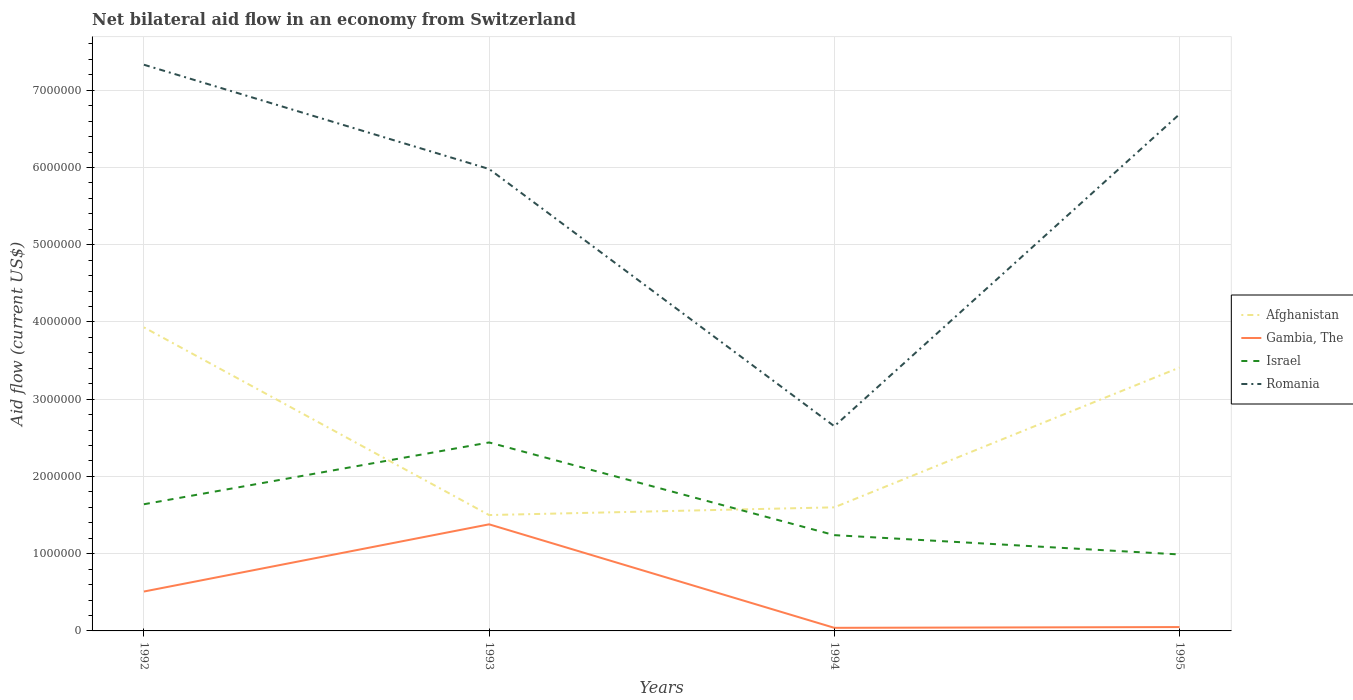Does the line corresponding to Israel intersect with the line corresponding to Afghanistan?
Provide a succinct answer. Yes. Is the number of lines equal to the number of legend labels?
Offer a very short reply. Yes. Across all years, what is the maximum net bilateral aid flow in Israel?
Offer a terse response. 9.90e+05. In which year was the net bilateral aid flow in Romania maximum?
Your answer should be compact. 1994. What is the total net bilateral aid flow in Israel in the graph?
Your answer should be very brief. 2.50e+05. What is the difference between the highest and the second highest net bilateral aid flow in Gambia, The?
Offer a very short reply. 1.34e+06. What is the difference between the highest and the lowest net bilateral aid flow in Romania?
Your answer should be compact. 3. How many lines are there?
Provide a short and direct response. 4. How many years are there in the graph?
Your answer should be compact. 4. What is the difference between two consecutive major ticks on the Y-axis?
Offer a terse response. 1.00e+06. Are the values on the major ticks of Y-axis written in scientific E-notation?
Your response must be concise. No. Does the graph contain any zero values?
Your answer should be compact. No. Where does the legend appear in the graph?
Your answer should be compact. Center right. How many legend labels are there?
Give a very brief answer. 4. How are the legend labels stacked?
Your response must be concise. Vertical. What is the title of the graph?
Offer a terse response. Net bilateral aid flow in an economy from Switzerland. What is the label or title of the Y-axis?
Ensure brevity in your answer.  Aid flow (current US$). What is the Aid flow (current US$) of Afghanistan in 1992?
Keep it short and to the point. 3.93e+06. What is the Aid flow (current US$) of Gambia, The in 1992?
Your answer should be compact. 5.10e+05. What is the Aid flow (current US$) of Israel in 1992?
Make the answer very short. 1.64e+06. What is the Aid flow (current US$) in Romania in 1992?
Provide a short and direct response. 7.33e+06. What is the Aid flow (current US$) of Afghanistan in 1993?
Your answer should be compact. 1.50e+06. What is the Aid flow (current US$) in Gambia, The in 1993?
Your response must be concise. 1.38e+06. What is the Aid flow (current US$) in Israel in 1993?
Your answer should be compact. 2.44e+06. What is the Aid flow (current US$) of Romania in 1993?
Provide a succinct answer. 5.98e+06. What is the Aid flow (current US$) of Afghanistan in 1994?
Your answer should be compact. 1.60e+06. What is the Aid flow (current US$) in Israel in 1994?
Your answer should be very brief. 1.24e+06. What is the Aid flow (current US$) of Romania in 1994?
Provide a succinct answer. 2.65e+06. What is the Aid flow (current US$) in Afghanistan in 1995?
Give a very brief answer. 3.41e+06. What is the Aid flow (current US$) of Israel in 1995?
Ensure brevity in your answer.  9.90e+05. What is the Aid flow (current US$) of Romania in 1995?
Your answer should be compact. 6.69e+06. Across all years, what is the maximum Aid flow (current US$) of Afghanistan?
Offer a very short reply. 3.93e+06. Across all years, what is the maximum Aid flow (current US$) of Gambia, The?
Your response must be concise. 1.38e+06. Across all years, what is the maximum Aid flow (current US$) in Israel?
Your answer should be very brief. 2.44e+06. Across all years, what is the maximum Aid flow (current US$) of Romania?
Ensure brevity in your answer.  7.33e+06. Across all years, what is the minimum Aid flow (current US$) of Afghanistan?
Provide a short and direct response. 1.50e+06. Across all years, what is the minimum Aid flow (current US$) of Gambia, The?
Offer a terse response. 4.00e+04. Across all years, what is the minimum Aid flow (current US$) of Israel?
Keep it short and to the point. 9.90e+05. Across all years, what is the minimum Aid flow (current US$) in Romania?
Your response must be concise. 2.65e+06. What is the total Aid flow (current US$) of Afghanistan in the graph?
Your response must be concise. 1.04e+07. What is the total Aid flow (current US$) of Gambia, The in the graph?
Offer a terse response. 1.98e+06. What is the total Aid flow (current US$) in Israel in the graph?
Provide a short and direct response. 6.31e+06. What is the total Aid flow (current US$) of Romania in the graph?
Provide a succinct answer. 2.26e+07. What is the difference between the Aid flow (current US$) of Afghanistan in 1992 and that in 1993?
Offer a terse response. 2.43e+06. What is the difference between the Aid flow (current US$) in Gambia, The in 1992 and that in 1993?
Provide a succinct answer. -8.70e+05. What is the difference between the Aid flow (current US$) in Israel in 1992 and that in 1993?
Ensure brevity in your answer.  -8.00e+05. What is the difference between the Aid flow (current US$) in Romania in 1992 and that in 1993?
Provide a short and direct response. 1.35e+06. What is the difference between the Aid flow (current US$) in Afghanistan in 1992 and that in 1994?
Provide a succinct answer. 2.33e+06. What is the difference between the Aid flow (current US$) in Gambia, The in 1992 and that in 1994?
Make the answer very short. 4.70e+05. What is the difference between the Aid flow (current US$) of Romania in 1992 and that in 1994?
Your response must be concise. 4.68e+06. What is the difference between the Aid flow (current US$) in Afghanistan in 1992 and that in 1995?
Your response must be concise. 5.20e+05. What is the difference between the Aid flow (current US$) of Gambia, The in 1992 and that in 1995?
Your response must be concise. 4.60e+05. What is the difference between the Aid flow (current US$) in Israel in 1992 and that in 1995?
Provide a short and direct response. 6.50e+05. What is the difference between the Aid flow (current US$) in Romania in 1992 and that in 1995?
Give a very brief answer. 6.40e+05. What is the difference between the Aid flow (current US$) in Afghanistan in 1993 and that in 1994?
Your response must be concise. -1.00e+05. What is the difference between the Aid flow (current US$) of Gambia, The in 1993 and that in 1994?
Keep it short and to the point. 1.34e+06. What is the difference between the Aid flow (current US$) in Israel in 1993 and that in 1994?
Offer a terse response. 1.20e+06. What is the difference between the Aid flow (current US$) in Romania in 1993 and that in 1994?
Make the answer very short. 3.33e+06. What is the difference between the Aid flow (current US$) in Afghanistan in 1993 and that in 1995?
Offer a very short reply. -1.91e+06. What is the difference between the Aid flow (current US$) in Gambia, The in 1993 and that in 1995?
Give a very brief answer. 1.33e+06. What is the difference between the Aid flow (current US$) of Israel in 1993 and that in 1995?
Give a very brief answer. 1.45e+06. What is the difference between the Aid flow (current US$) of Romania in 1993 and that in 1995?
Your answer should be compact. -7.10e+05. What is the difference between the Aid flow (current US$) of Afghanistan in 1994 and that in 1995?
Give a very brief answer. -1.81e+06. What is the difference between the Aid flow (current US$) in Israel in 1994 and that in 1995?
Provide a succinct answer. 2.50e+05. What is the difference between the Aid flow (current US$) in Romania in 1994 and that in 1995?
Provide a succinct answer. -4.04e+06. What is the difference between the Aid flow (current US$) in Afghanistan in 1992 and the Aid flow (current US$) in Gambia, The in 1993?
Provide a succinct answer. 2.55e+06. What is the difference between the Aid flow (current US$) in Afghanistan in 1992 and the Aid flow (current US$) in Israel in 1993?
Provide a short and direct response. 1.49e+06. What is the difference between the Aid flow (current US$) of Afghanistan in 1992 and the Aid flow (current US$) of Romania in 1993?
Give a very brief answer. -2.05e+06. What is the difference between the Aid flow (current US$) of Gambia, The in 1992 and the Aid flow (current US$) of Israel in 1993?
Keep it short and to the point. -1.93e+06. What is the difference between the Aid flow (current US$) of Gambia, The in 1992 and the Aid flow (current US$) of Romania in 1993?
Provide a short and direct response. -5.47e+06. What is the difference between the Aid flow (current US$) of Israel in 1992 and the Aid flow (current US$) of Romania in 1993?
Provide a short and direct response. -4.34e+06. What is the difference between the Aid flow (current US$) in Afghanistan in 1992 and the Aid flow (current US$) in Gambia, The in 1994?
Make the answer very short. 3.89e+06. What is the difference between the Aid flow (current US$) in Afghanistan in 1992 and the Aid flow (current US$) in Israel in 1994?
Make the answer very short. 2.69e+06. What is the difference between the Aid flow (current US$) in Afghanistan in 1992 and the Aid flow (current US$) in Romania in 1994?
Keep it short and to the point. 1.28e+06. What is the difference between the Aid flow (current US$) of Gambia, The in 1992 and the Aid flow (current US$) of Israel in 1994?
Provide a short and direct response. -7.30e+05. What is the difference between the Aid flow (current US$) of Gambia, The in 1992 and the Aid flow (current US$) of Romania in 1994?
Make the answer very short. -2.14e+06. What is the difference between the Aid flow (current US$) of Israel in 1992 and the Aid flow (current US$) of Romania in 1994?
Provide a short and direct response. -1.01e+06. What is the difference between the Aid flow (current US$) of Afghanistan in 1992 and the Aid flow (current US$) of Gambia, The in 1995?
Your response must be concise. 3.88e+06. What is the difference between the Aid flow (current US$) of Afghanistan in 1992 and the Aid flow (current US$) of Israel in 1995?
Your response must be concise. 2.94e+06. What is the difference between the Aid flow (current US$) in Afghanistan in 1992 and the Aid flow (current US$) in Romania in 1995?
Provide a succinct answer. -2.76e+06. What is the difference between the Aid flow (current US$) in Gambia, The in 1992 and the Aid flow (current US$) in Israel in 1995?
Provide a succinct answer. -4.80e+05. What is the difference between the Aid flow (current US$) of Gambia, The in 1992 and the Aid flow (current US$) of Romania in 1995?
Provide a succinct answer. -6.18e+06. What is the difference between the Aid flow (current US$) in Israel in 1992 and the Aid flow (current US$) in Romania in 1995?
Provide a short and direct response. -5.05e+06. What is the difference between the Aid flow (current US$) of Afghanistan in 1993 and the Aid flow (current US$) of Gambia, The in 1994?
Keep it short and to the point. 1.46e+06. What is the difference between the Aid flow (current US$) in Afghanistan in 1993 and the Aid flow (current US$) in Israel in 1994?
Your answer should be very brief. 2.60e+05. What is the difference between the Aid flow (current US$) in Afghanistan in 1993 and the Aid flow (current US$) in Romania in 1994?
Provide a short and direct response. -1.15e+06. What is the difference between the Aid flow (current US$) of Gambia, The in 1993 and the Aid flow (current US$) of Romania in 1994?
Offer a very short reply. -1.27e+06. What is the difference between the Aid flow (current US$) of Afghanistan in 1993 and the Aid flow (current US$) of Gambia, The in 1995?
Give a very brief answer. 1.45e+06. What is the difference between the Aid flow (current US$) in Afghanistan in 1993 and the Aid flow (current US$) in Israel in 1995?
Ensure brevity in your answer.  5.10e+05. What is the difference between the Aid flow (current US$) in Afghanistan in 1993 and the Aid flow (current US$) in Romania in 1995?
Offer a very short reply. -5.19e+06. What is the difference between the Aid flow (current US$) of Gambia, The in 1993 and the Aid flow (current US$) of Israel in 1995?
Your response must be concise. 3.90e+05. What is the difference between the Aid flow (current US$) of Gambia, The in 1993 and the Aid flow (current US$) of Romania in 1995?
Ensure brevity in your answer.  -5.31e+06. What is the difference between the Aid flow (current US$) in Israel in 1993 and the Aid flow (current US$) in Romania in 1995?
Your answer should be very brief. -4.25e+06. What is the difference between the Aid flow (current US$) in Afghanistan in 1994 and the Aid flow (current US$) in Gambia, The in 1995?
Provide a succinct answer. 1.55e+06. What is the difference between the Aid flow (current US$) in Afghanistan in 1994 and the Aid flow (current US$) in Israel in 1995?
Ensure brevity in your answer.  6.10e+05. What is the difference between the Aid flow (current US$) in Afghanistan in 1994 and the Aid flow (current US$) in Romania in 1995?
Your answer should be very brief. -5.09e+06. What is the difference between the Aid flow (current US$) in Gambia, The in 1994 and the Aid flow (current US$) in Israel in 1995?
Your answer should be compact. -9.50e+05. What is the difference between the Aid flow (current US$) of Gambia, The in 1994 and the Aid flow (current US$) of Romania in 1995?
Your response must be concise. -6.65e+06. What is the difference between the Aid flow (current US$) of Israel in 1994 and the Aid flow (current US$) of Romania in 1995?
Keep it short and to the point. -5.45e+06. What is the average Aid flow (current US$) of Afghanistan per year?
Your answer should be very brief. 2.61e+06. What is the average Aid flow (current US$) of Gambia, The per year?
Offer a very short reply. 4.95e+05. What is the average Aid flow (current US$) in Israel per year?
Offer a very short reply. 1.58e+06. What is the average Aid flow (current US$) in Romania per year?
Provide a short and direct response. 5.66e+06. In the year 1992, what is the difference between the Aid flow (current US$) in Afghanistan and Aid flow (current US$) in Gambia, The?
Ensure brevity in your answer.  3.42e+06. In the year 1992, what is the difference between the Aid flow (current US$) in Afghanistan and Aid flow (current US$) in Israel?
Keep it short and to the point. 2.29e+06. In the year 1992, what is the difference between the Aid flow (current US$) of Afghanistan and Aid flow (current US$) of Romania?
Give a very brief answer. -3.40e+06. In the year 1992, what is the difference between the Aid flow (current US$) in Gambia, The and Aid flow (current US$) in Israel?
Make the answer very short. -1.13e+06. In the year 1992, what is the difference between the Aid flow (current US$) in Gambia, The and Aid flow (current US$) in Romania?
Provide a succinct answer. -6.82e+06. In the year 1992, what is the difference between the Aid flow (current US$) of Israel and Aid flow (current US$) of Romania?
Offer a very short reply. -5.69e+06. In the year 1993, what is the difference between the Aid flow (current US$) in Afghanistan and Aid flow (current US$) in Gambia, The?
Make the answer very short. 1.20e+05. In the year 1993, what is the difference between the Aid flow (current US$) of Afghanistan and Aid flow (current US$) of Israel?
Make the answer very short. -9.40e+05. In the year 1993, what is the difference between the Aid flow (current US$) in Afghanistan and Aid flow (current US$) in Romania?
Your answer should be compact. -4.48e+06. In the year 1993, what is the difference between the Aid flow (current US$) in Gambia, The and Aid flow (current US$) in Israel?
Make the answer very short. -1.06e+06. In the year 1993, what is the difference between the Aid flow (current US$) of Gambia, The and Aid flow (current US$) of Romania?
Ensure brevity in your answer.  -4.60e+06. In the year 1993, what is the difference between the Aid flow (current US$) of Israel and Aid flow (current US$) of Romania?
Your answer should be compact. -3.54e+06. In the year 1994, what is the difference between the Aid flow (current US$) of Afghanistan and Aid flow (current US$) of Gambia, The?
Provide a short and direct response. 1.56e+06. In the year 1994, what is the difference between the Aid flow (current US$) of Afghanistan and Aid flow (current US$) of Israel?
Make the answer very short. 3.60e+05. In the year 1994, what is the difference between the Aid flow (current US$) in Afghanistan and Aid flow (current US$) in Romania?
Provide a short and direct response. -1.05e+06. In the year 1994, what is the difference between the Aid flow (current US$) in Gambia, The and Aid flow (current US$) in Israel?
Your response must be concise. -1.20e+06. In the year 1994, what is the difference between the Aid flow (current US$) in Gambia, The and Aid flow (current US$) in Romania?
Your answer should be very brief. -2.61e+06. In the year 1994, what is the difference between the Aid flow (current US$) in Israel and Aid flow (current US$) in Romania?
Give a very brief answer. -1.41e+06. In the year 1995, what is the difference between the Aid flow (current US$) in Afghanistan and Aid flow (current US$) in Gambia, The?
Offer a terse response. 3.36e+06. In the year 1995, what is the difference between the Aid flow (current US$) of Afghanistan and Aid flow (current US$) of Israel?
Your answer should be very brief. 2.42e+06. In the year 1995, what is the difference between the Aid flow (current US$) in Afghanistan and Aid flow (current US$) in Romania?
Ensure brevity in your answer.  -3.28e+06. In the year 1995, what is the difference between the Aid flow (current US$) in Gambia, The and Aid flow (current US$) in Israel?
Make the answer very short. -9.40e+05. In the year 1995, what is the difference between the Aid flow (current US$) of Gambia, The and Aid flow (current US$) of Romania?
Make the answer very short. -6.64e+06. In the year 1995, what is the difference between the Aid flow (current US$) of Israel and Aid flow (current US$) of Romania?
Provide a succinct answer. -5.70e+06. What is the ratio of the Aid flow (current US$) of Afghanistan in 1992 to that in 1993?
Provide a succinct answer. 2.62. What is the ratio of the Aid flow (current US$) in Gambia, The in 1992 to that in 1993?
Provide a succinct answer. 0.37. What is the ratio of the Aid flow (current US$) in Israel in 1992 to that in 1993?
Keep it short and to the point. 0.67. What is the ratio of the Aid flow (current US$) of Romania in 1992 to that in 1993?
Provide a short and direct response. 1.23. What is the ratio of the Aid flow (current US$) in Afghanistan in 1992 to that in 1994?
Give a very brief answer. 2.46. What is the ratio of the Aid flow (current US$) of Gambia, The in 1992 to that in 1994?
Your answer should be very brief. 12.75. What is the ratio of the Aid flow (current US$) of Israel in 1992 to that in 1994?
Provide a succinct answer. 1.32. What is the ratio of the Aid flow (current US$) in Romania in 1992 to that in 1994?
Your answer should be compact. 2.77. What is the ratio of the Aid flow (current US$) in Afghanistan in 1992 to that in 1995?
Provide a short and direct response. 1.15. What is the ratio of the Aid flow (current US$) of Israel in 1992 to that in 1995?
Ensure brevity in your answer.  1.66. What is the ratio of the Aid flow (current US$) of Romania in 1992 to that in 1995?
Give a very brief answer. 1.1. What is the ratio of the Aid flow (current US$) in Gambia, The in 1993 to that in 1994?
Provide a short and direct response. 34.5. What is the ratio of the Aid flow (current US$) in Israel in 1993 to that in 1994?
Your answer should be compact. 1.97. What is the ratio of the Aid flow (current US$) in Romania in 1993 to that in 1994?
Make the answer very short. 2.26. What is the ratio of the Aid flow (current US$) in Afghanistan in 1993 to that in 1995?
Keep it short and to the point. 0.44. What is the ratio of the Aid flow (current US$) of Gambia, The in 1993 to that in 1995?
Your response must be concise. 27.6. What is the ratio of the Aid flow (current US$) of Israel in 1993 to that in 1995?
Offer a very short reply. 2.46. What is the ratio of the Aid flow (current US$) in Romania in 1993 to that in 1995?
Keep it short and to the point. 0.89. What is the ratio of the Aid flow (current US$) of Afghanistan in 1994 to that in 1995?
Your answer should be very brief. 0.47. What is the ratio of the Aid flow (current US$) in Gambia, The in 1994 to that in 1995?
Keep it short and to the point. 0.8. What is the ratio of the Aid flow (current US$) in Israel in 1994 to that in 1995?
Make the answer very short. 1.25. What is the ratio of the Aid flow (current US$) of Romania in 1994 to that in 1995?
Offer a very short reply. 0.4. What is the difference between the highest and the second highest Aid flow (current US$) in Afghanistan?
Your response must be concise. 5.20e+05. What is the difference between the highest and the second highest Aid flow (current US$) in Gambia, The?
Offer a very short reply. 8.70e+05. What is the difference between the highest and the second highest Aid flow (current US$) of Israel?
Provide a short and direct response. 8.00e+05. What is the difference between the highest and the second highest Aid flow (current US$) of Romania?
Keep it short and to the point. 6.40e+05. What is the difference between the highest and the lowest Aid flow (current US$) in Afghanistan?
Provide a short and direct response. 2.43e+06. What is the difference between the highest and the lowest Aid flow (current US$) of Gambia, The?
Your answer should be compact. 1.34e+06. What is the difference between the highest and the lowest Aid flow (current US$) in Israel?
Give a very brief answer. 1.45e+06. What is the difference between the highest and the lowest Aid flow (current US$) in Romania?
Keep it short and to the point. 4.68e+06. 